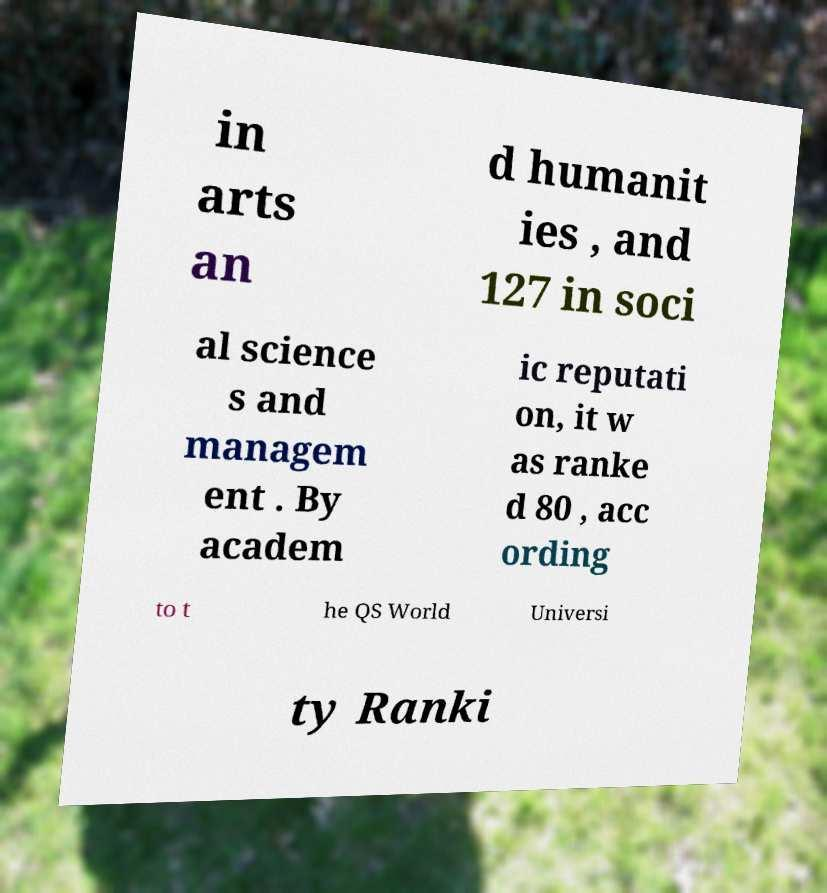What messages or text are displayed in this image? I need them in a readable, typed format. in arts an d humanit ies , and 127 in soci al science s and managem ent . By academ ic reputati on, it w as ranke d 80 , acc ording to t he QS World Universi ty Ranki 